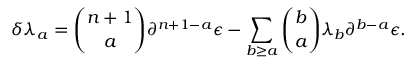<formula> <loc_0><loc_0><loc_500><loc_500>\delta \lambda _ { a } = { \binom { n + 1 } { a } } \partial ^ { n + 1 - a } \epsilon - \sum _ { b \geq a } { \binom { b } { a } } \lambda _ { b } \partial ^ { b - a } \epsilon .</formula> 